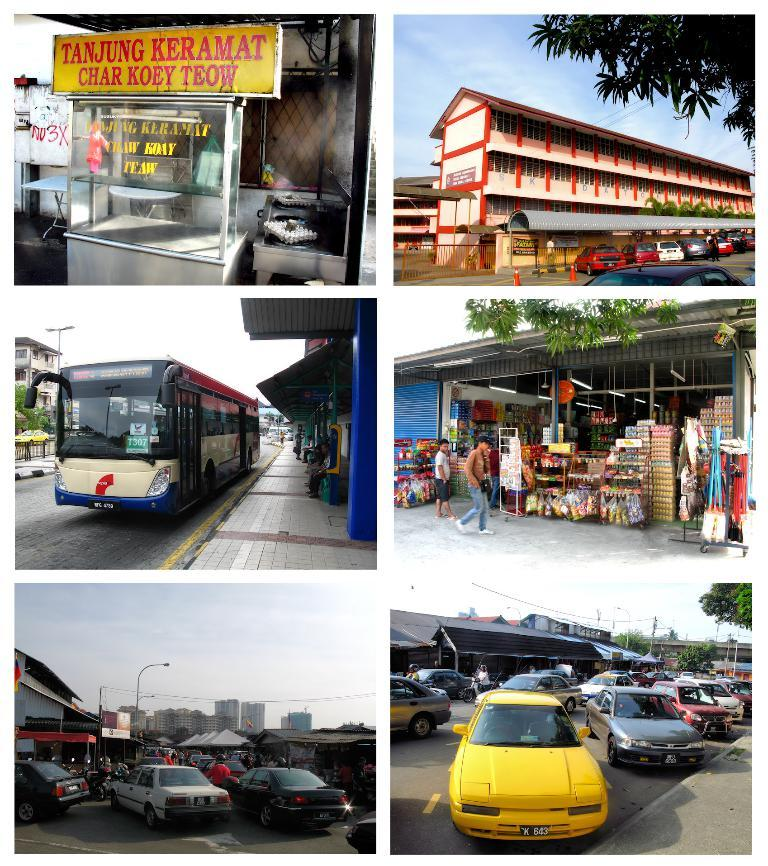What type of artwork is the image? The image is a collage. What can be seen on the name boards in the image? The content of the name boards cannot be determined from the image. What type of structures are depicted in the image? There are buildings in the image. What type of transportation is present in the image? There are vehicles in the image. What safety feature is present in the image? There are traffic cones in the image. What type of pathways are depicted in the image? There are roads in the image. What type of vegetation is present in the image? There are trees in the image. What other objects can be seen in the image? There are various objects in the image. What is visible in the background of the image? The sky is visible in the background of the image. How many kisses can be seen on the memory in the image? There is no memory or kisses present in the image. What type of needle is used to sew the fabric in the image? There is no fabric or needle present in the image. 